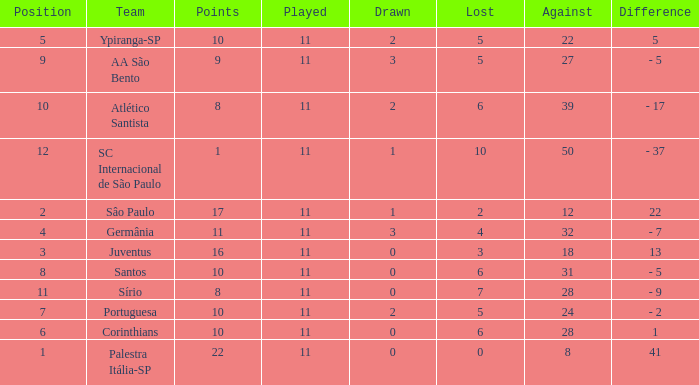When the value difference is 13 and the value lost is more than 3, what is the total count of points? None. Would you be able to parse every entry in this table? {'header': ['Position', 'Team', 'Points', 'Played', 'Drawn', 'Lost', 'Against', 'Difference'], 'rows': [['5', 'Ypiranga-SP', '10', '11', '2', '5', '22', '5'], ['9', 'AA São Bento', '9', '11', '3', '5', '27', '- 5'], ['10', 'Atlético Santista', '8', '11', '2', '6', '39', '- 17'], ['12', 'SC Internacional de São Paulo', '1', '11', '1', '10', '50', '- 37'], ['2', 'Sâo Paulo', '17', '11', '1', '2', '12', '22'], ['4', 'Germânia', '11', '11', '3', '4', '32', '- 7'], ['3', 'Juventus', '16', '11', '0', '3', '18', '13'], ['8', 'Santos', '10', '11', '0', '6', '31', '- 5'], ['11', 'Sírio', '8', '11', '0', '7', '28', '- 9'], ['7', 'Portuguesa', '10', '11', '2', '5', '24', '- 2'], ['6', 'Corinthians', '10', '11', '0', '6', '28', '1'], ['1', 'Palestra Itália-SP', '22', '11', '0', '0', '8', '41']]} 